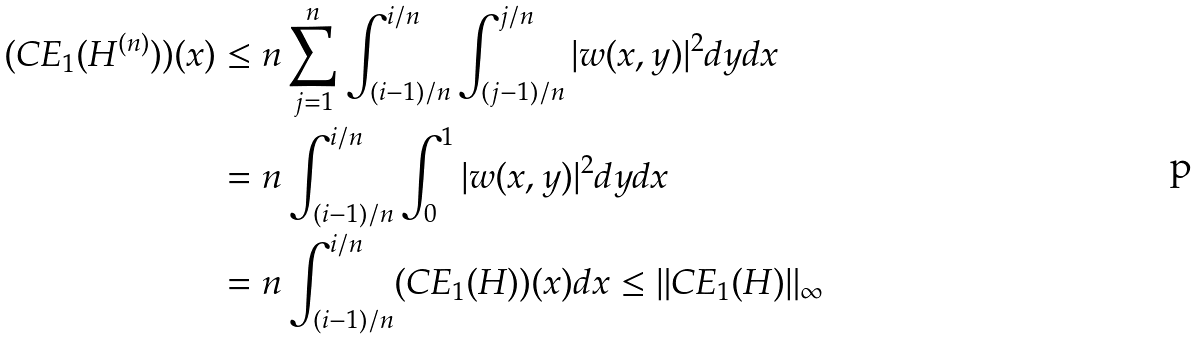Convert formula to latex. <formula><loc_0><loc_0><loc_500><loc_500>( C E _ { 1 } ( H ^ { ( n ) } ) ) ( x ) & \leq n \sum _ { j = 1 } ^ { n } \int _ { ( i - 1 ) / n } ^ { i / n } \int _ { ( j - 1 ) / n } ^ { j / n } | w ( x , y ) | ^ { 2 } d y d x \\ & = n \int _ { ( i - 1 ) / n } ^ { i / n } \int _ { 0 } ^ { 1 } | w ( x , y ) | ^ { 2 } d y d x \\ & = n \int _ { ( i - 1 ) / n } ^ { i / n } ( C E _ { 1 } ( H ) ) ( x ) d x \leq \| C E _ { 1 } ( H ) \| _ { \infty }</formula> 